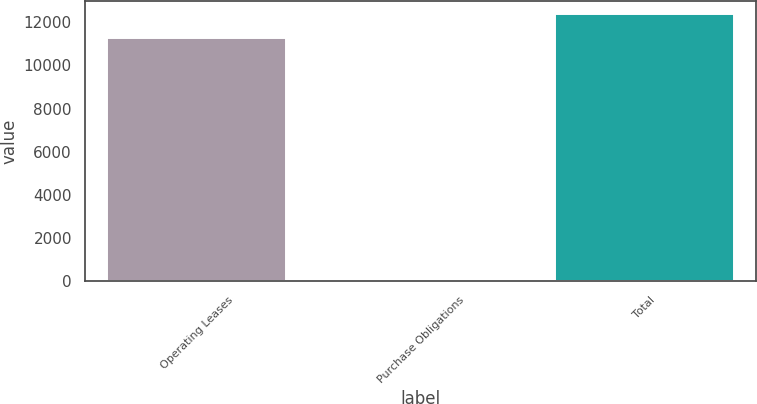Convert chart. <chart><loc_0><loc_0><loc_500><loc_500><bar_chart><fcel>Operating Leases<fcel>Purchase Obligations<fcel>Total<nl><fcel>11241<fcel>4.92<fcel>12364.6<nl></chart> 